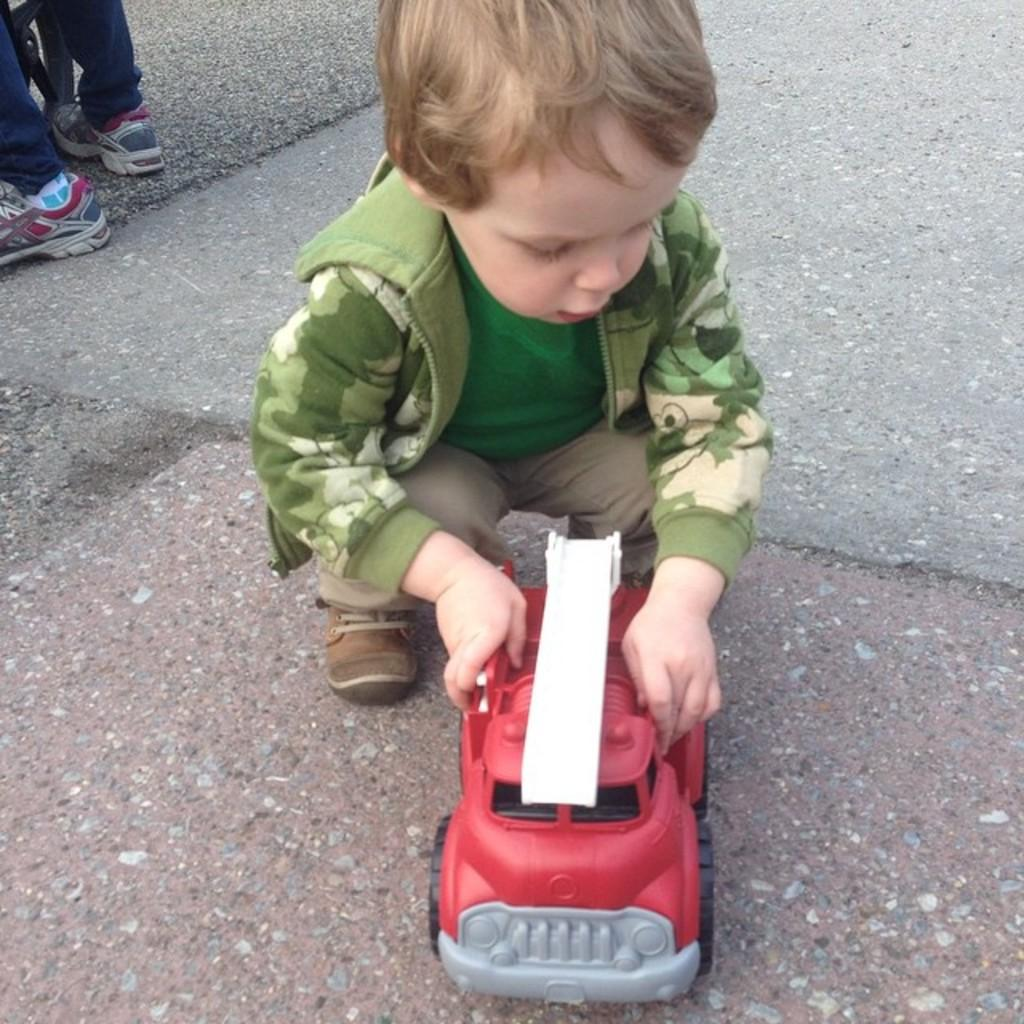Who is present in the image? There is a boy in the image. What is the boy holding? The boy is holding a toy. What can be seen in the background of the image? There is a person standing at a vehicle in the background. What type of surface is visible in the image? There is a floor visible in the image. Where is the kettle located in the image? There is no kettle present in the image. How many balls are visible in the image? There are no balls visible in the image. 